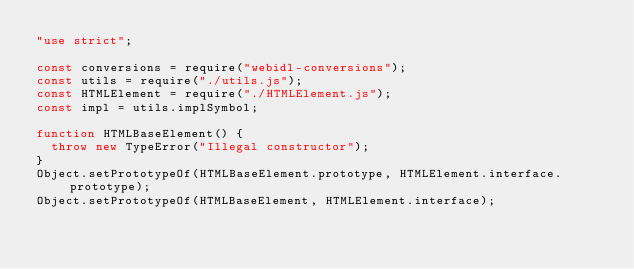Convert code to text. <code><loc_0><loc_0><loc_500><loc_500><_JavaScript_>"use strict";

const conversions = require("webidl-conversions");
const utils = require("./utils.js");
const HTMLElement = require("./HTMLElement.js");
const impl = utils.implSymbol;

function HTMLBaseElement() {
  throw new TypeError("Illegal constructor");
}
Object.setPrototypeOf(HTMLBaseElement.prototype, HTMLElement.interface.prototype);
Object.setPrototypeOf(HTMLBaseElement, HTMLElement.interface);
</code> 